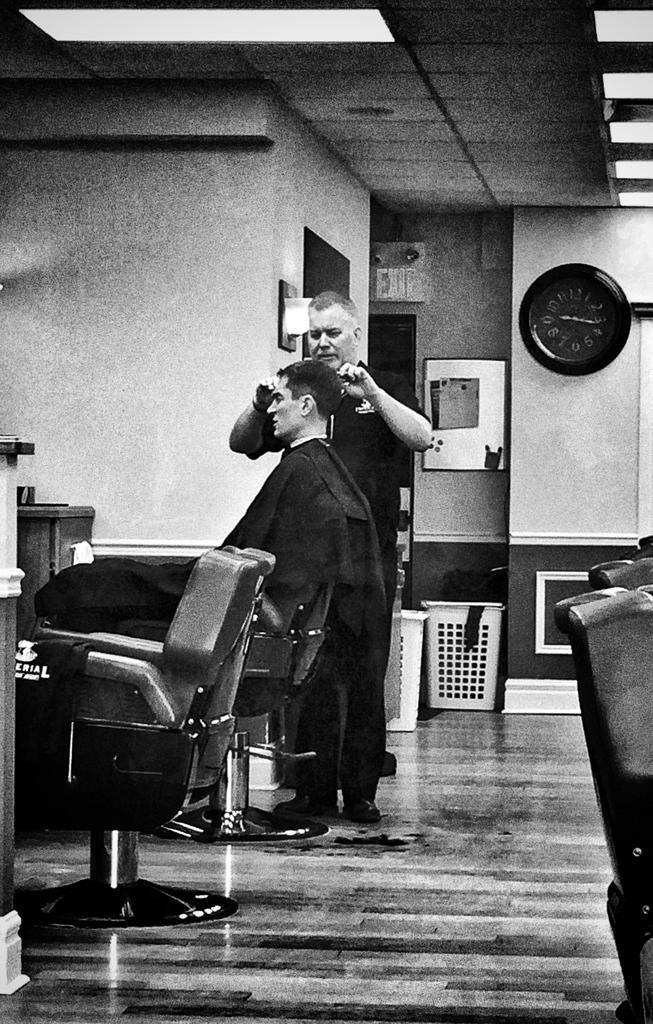Describe this image in one or two sentences. This is a black and white image. This picture is taken in the room. In this image, in the middle, we can see a man wearing a black color shirt is standing and holding some object in his hand. In the middle of the image, we can also see another person sitting on the chair. In the right corner, we can also see a chair. On the left side, we can also see a chair. In the background, we can also see a chair, boxes. In the background, we can see a clock which is attached to a wall and some objects which are attached to a wall. On the left side, we can see a table. At the top, we can see a roof with few lights, at the bottom, we can see a roof. 